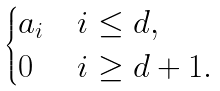<formula> <loc_0><loc_0><loc_500><loc_500>\begin{cases} a _ { i } & i \leq d , \\ 0 & i \geq d + 1 . \end{cases}</formula> 